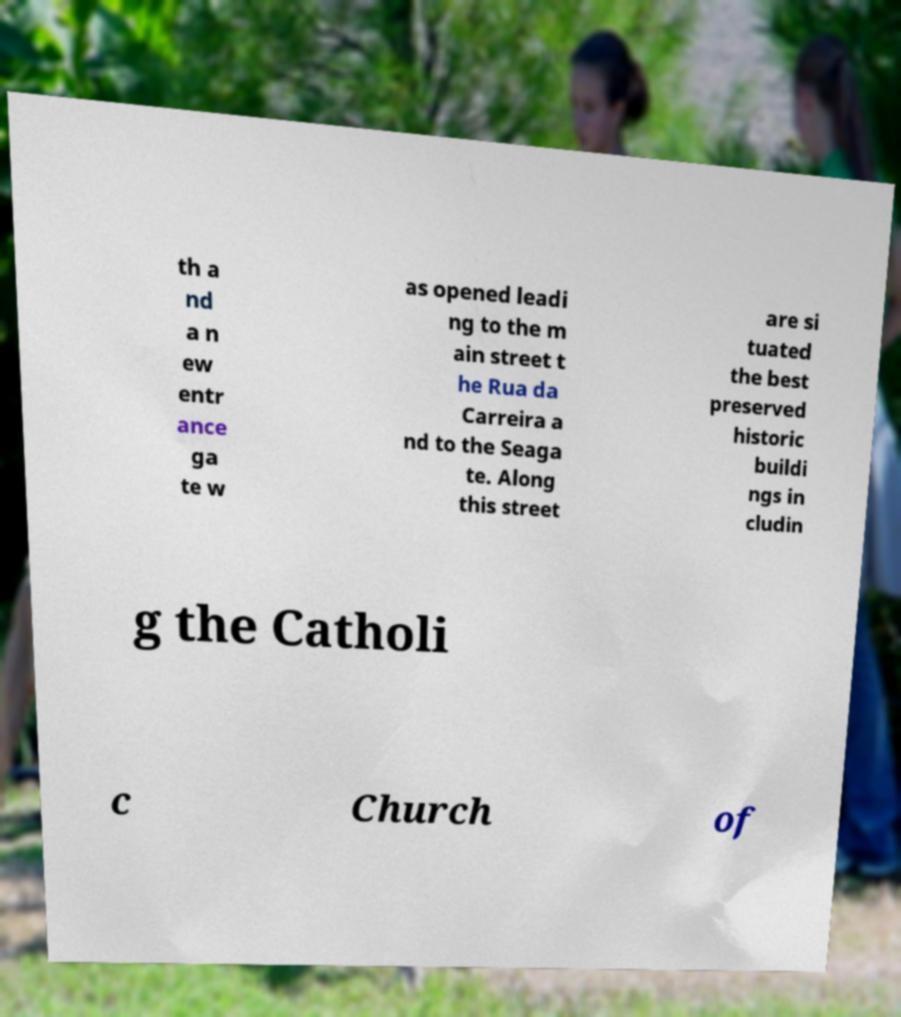I need the written content from this picture converted into text. Can you do that? th a nd a n ew entr ance ga te w as opened leadi ng to the m ain street t he Rua da Carreira a nd to the Seaga te. Along this street are si tuated the best preserved historic buildi ngs in cludin g the Catholi c Church of 